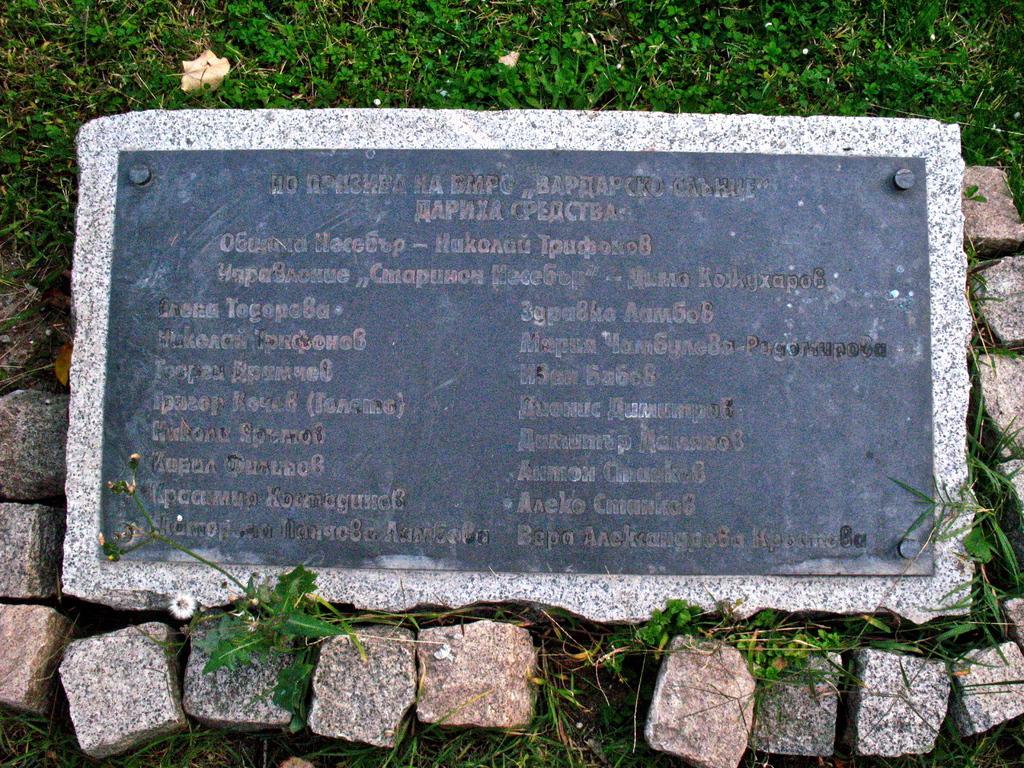Can you describe this image briefly? In this image there is a stone board with text and it is placed on the grass. Image also consists of stones. 